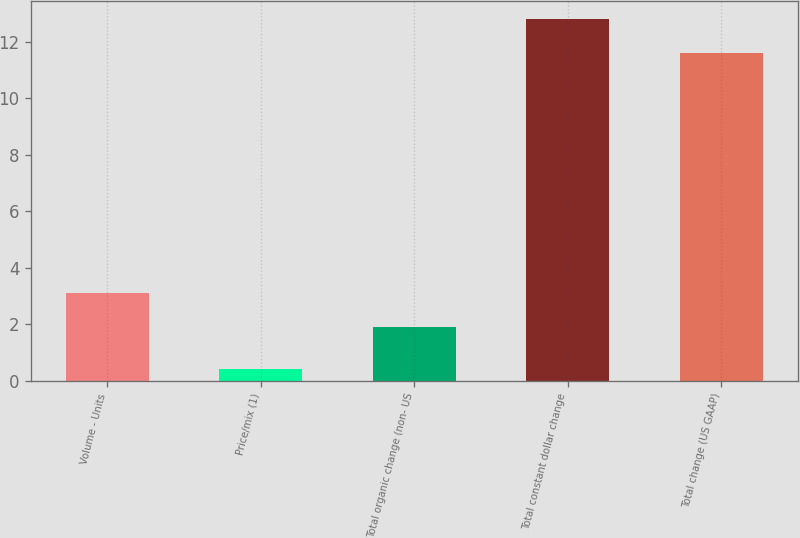Convert chart to OTSL. <chart><loc_0><loc_0><loc_500><loc_500><bar_chart><fcel>Volume - Units<fcel>Price/mix (1)<fcel>Total organic change (non- US<fcel>Total constant dollar change<fcel>Total change (US GAAP)<nl><fcel>3.1<fcel>0.4<fcel>1.9<fcel>12.8<fcel>11.6<nl></chart> 